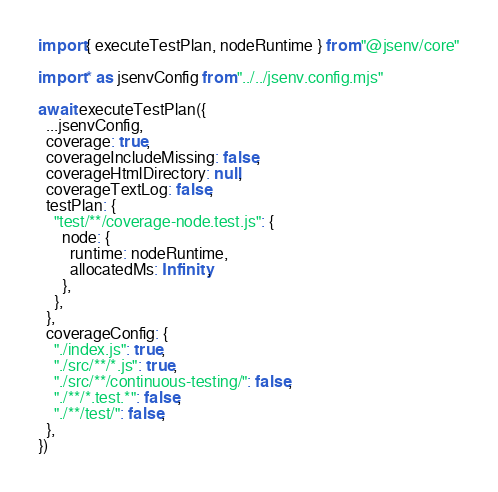Convert code to text. <code><loc_0><loc_0><loc_500><loc_500><_JavaScript_>import { executeTestPlan, nodeRuntime } from "@jsenv/core"

import * as jsenvConfig from "../../jsenv.config.mjs"

await executeTestPlan({
  ...jsenvConfig,
  coverage: true,
  coverageIncludeMissing: false,
  coverageHtmlDirectory: null,
  coverageTextLog: false,
  testPlan: {
    "test/**/coverage-node.test.js": {
      node: {
        runtime: nodeRuntime,
        allocatedMs: Infinity,
      },
    },
  },
  coverageConfig: {
    "./index.js": true,
    "./src/**/*.js": true,
    "./src/**/continuous-testing/": false,
    "./**/*.test.*": false,
    "./**/test/": false,
  },
})
</code> 